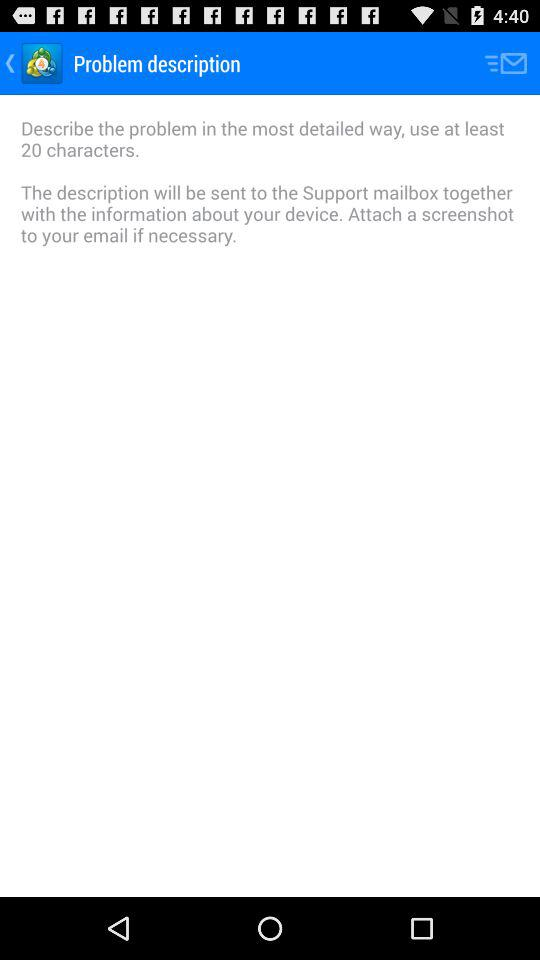What is the least number of characters required to describe the problem? The least number of characters required is 20. 